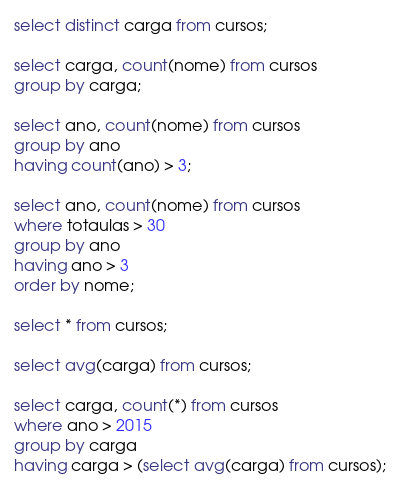Convert code to text. <code><loc_0><loc_0><loc_500><loc_500><_SQL_>select distinct carga from cursos;

select carga, count(nome) from cursos
group by carga;

select ano, count(nome) from cursos
group by ano
having count(ano) > 3;

select ano, count(nome) from cursos
where totaulas > 30
group by ano
having ano > 3
order by nome;

select * from cursos;

select avg(carga) from cursos;

select carga, count(*) from cursos
where ano > 2015
group by carga
having carga > (select avg(carga) from cursos);</code> 